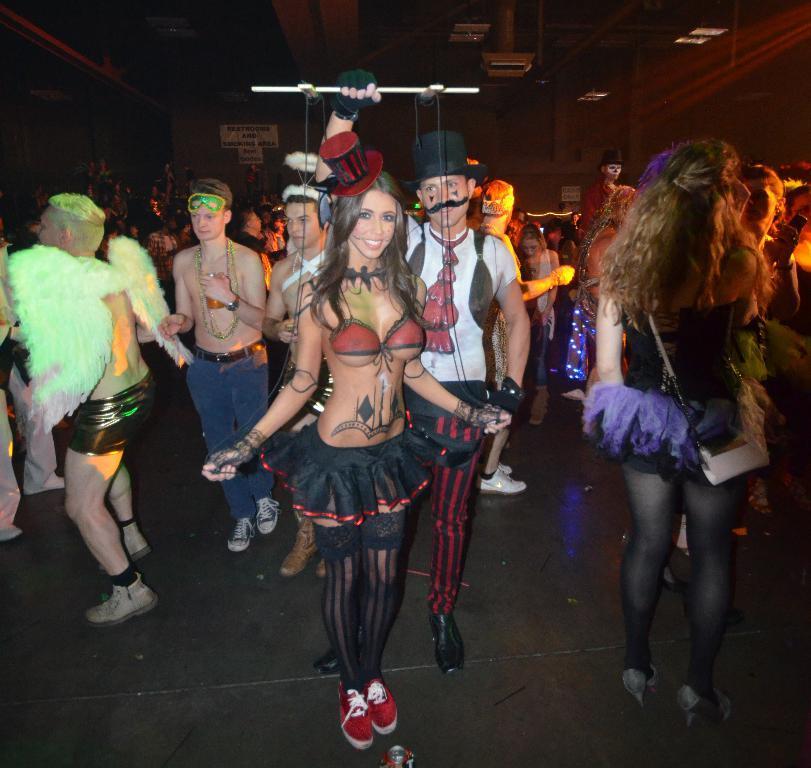Could you give a brief overview of what you see in this image? In this image we can see a group of people standing on the ground, some people are wearing costumes. On the right side of the image we can see a woman wearing the bag. One woman is holding a mobile in her hand. In the background, we can see a board with some text and some lights. 